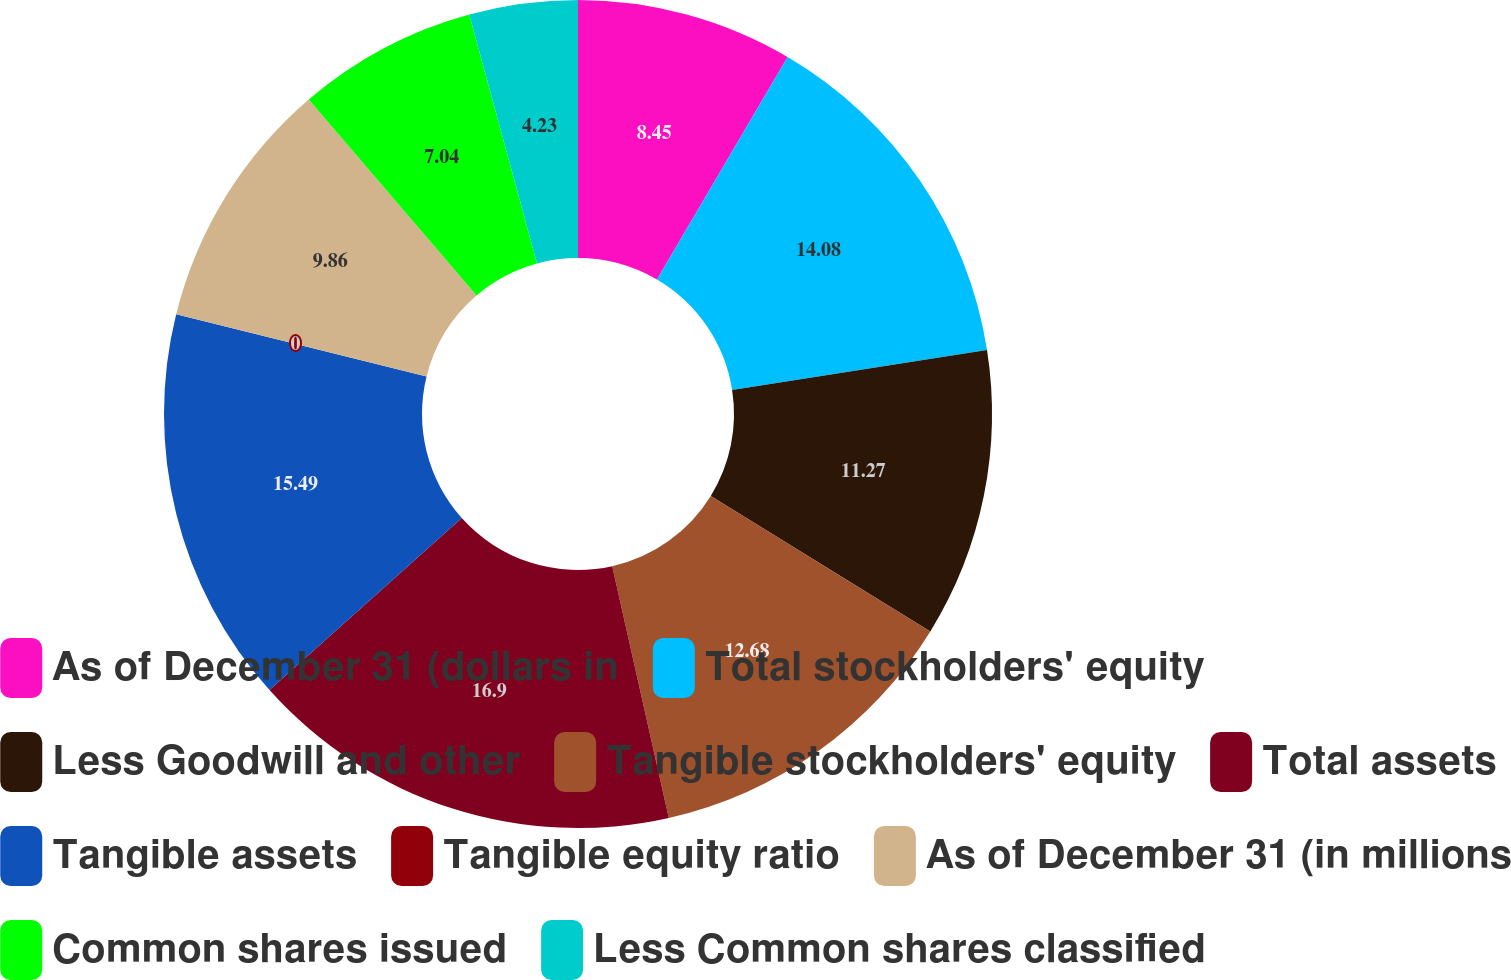Convert chart to OTSL. <chart><loc_0><loc_0><loc_500><loc_500><pie_chart><fcel>As of December 31 (dollars in<fcel>Total stockholders' equity<fcel>Less Goodwill and other<fcel>Tangible stockholders' equity<fcel>Total assets<fcel>Tangible assets<fcel>Tangible equity ratio<fcel>As of December 31 (in millions<fcel>Common shares issued<fcel>Less Common shares classified<nl><fcel>8.45%<fcel>14.08%<fcel>11.27%<fcel>12.68%<fcel>16.9%<fcel>15.49%<fcel>0.0%<fcel>9.86%<fcel>7.04%<fcel>4.23%<nl></chart> 